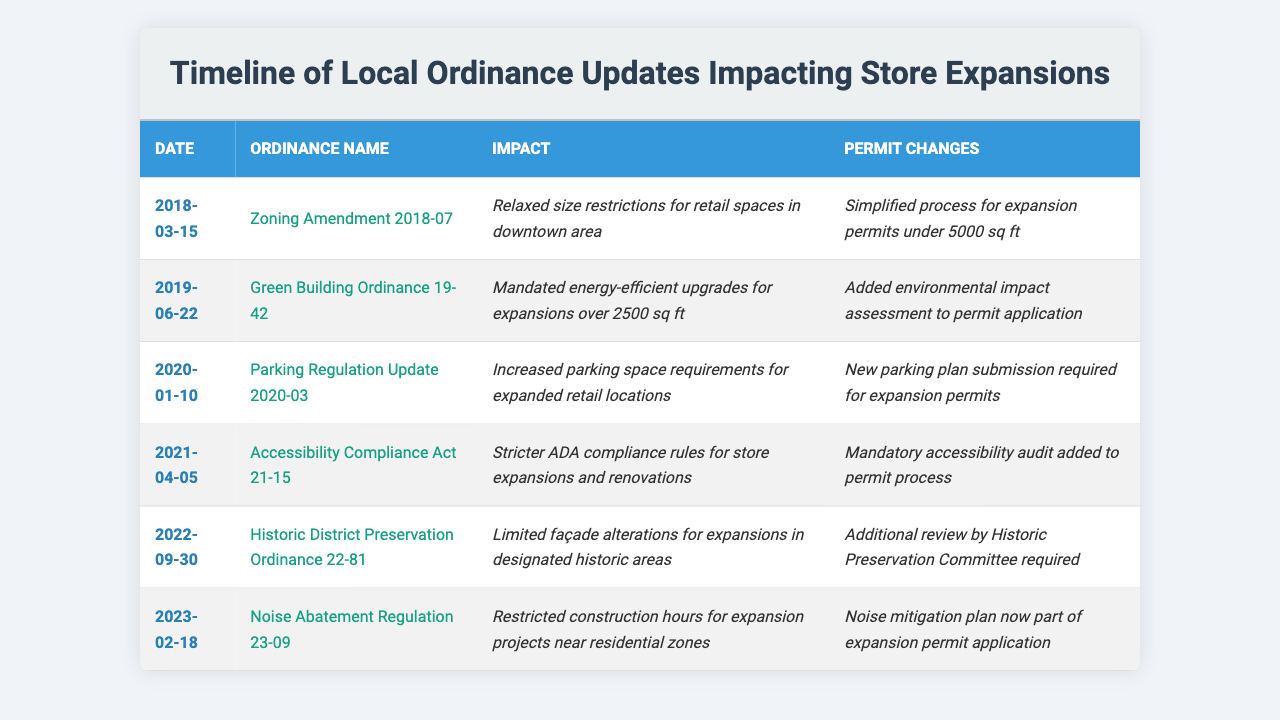What was the impact of the "Zoning Amendment 2018-07"? The table states that the "Zoning Amendment 2018-07" relaxed size restrictions for retail spaces in the downtown area.
Answer: Relaxed size restrictions What ordinance mandated energy-efficient upgrades? The "Green Building Ordinance 19-42" mandated energy-efficient upgrades for expansions over 2500 sq ft.
Answer: Green Building Ordinance 19-42 Did the "Accessibility Compliance Act 21-15" introduce a new permit process? Yes, it added a mandatory accessibility audit to the permit process for store expansions.
Answer: Yes Which ordinance was passed first, "Noise Abatement Regulation 23-09" or "Historic District Preservation Ordinance 22-81"? The "Historic District Preservation Ordinance 22-81" was passed on September 30, 2022, while the "Noise Abatement Regulation 23-09" was passed on February 18, 2023. Since September comes before February, the Historic District Preservation Ordinance was passed first.
Answer: Historic District Preservation Ordinance 22-81 How many ordinances require a review by a committee or additional assessment? There are two ordinances that require a review by a committee or additional assessment: the "Green Building Ordinance 19-42" which added an environmental impact assessment, and the "Historic District Preservation Ordinance 22-81" which requires additional review by the Historic Preservation Committee.
Answer: Two ordinances What are the permit changes introduced by the "Parking Regulation Update 2020-03"? The permit changes introduced by the "Parking Regulation Update 2020-03" include a new parking plan submission required for expansion permits.
Answer: New parking plan submission required What is the most recent ordinance affecting store expansions? The most recent ordinance affecting store expansions is the "Noise Abatement Regulation 23-09," passed on February 18, 2023.
Answer: Noise Abatement Regulation 23-09 If an expansion is over 2500 sq ft, which ordinances would apply? The ordinances that would apply for an expansion over 2500 sq ft are the "Green Building Ordinance 19-42," which mandates energy-efficient upgrades, and the "Accessibility Compliance Act 21-15," which has stricter ADA compliance.
Answer: Green Building Ordinance 19-42 and Accessibility Compliance Act 21-15 What changes did the "Noise Abatement Regulation 23-09" bring regarding construction hours? The "Noise Abatement Regulation 23-09" restricted construction hours for expansion projects near residential zones.
Answer: Restricted construction hours How does the "Historic District Preservation Ordinance 22-81" impact façade alterations? The "Historic District Preservation Ordinance 22-81" limited façade alterations for expansions in designated historic areas.
Answer: Limited façade alterations Which ordinance was introduced to address parking space requirements? The "Parking Regulation Update 2020-03" was introduced to increase parking space requirements for expanded retail locations.
Answer: Parking Regulation Update 2020-03 